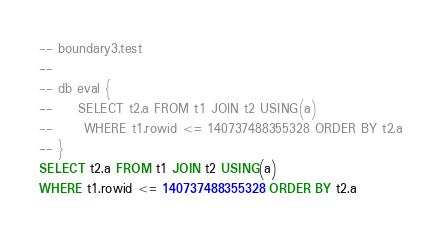Convert code to text. <code><loc_0><loc_0><loc_500><loc_500><_SQL_>-- boundary3.test
-- 
-- db eval {
--     SELECT t2.a FROM t1 JOIN t2 USING(a)
--      WHERE t1.rowid <= 140737488355328 ORDER BY t2.a
-- }
SELECT t2.a FROM t1 JOIN t2 USING(a)
WHERE t1.rowid <= 140737488355328 ORDER BY t2.a</code> 